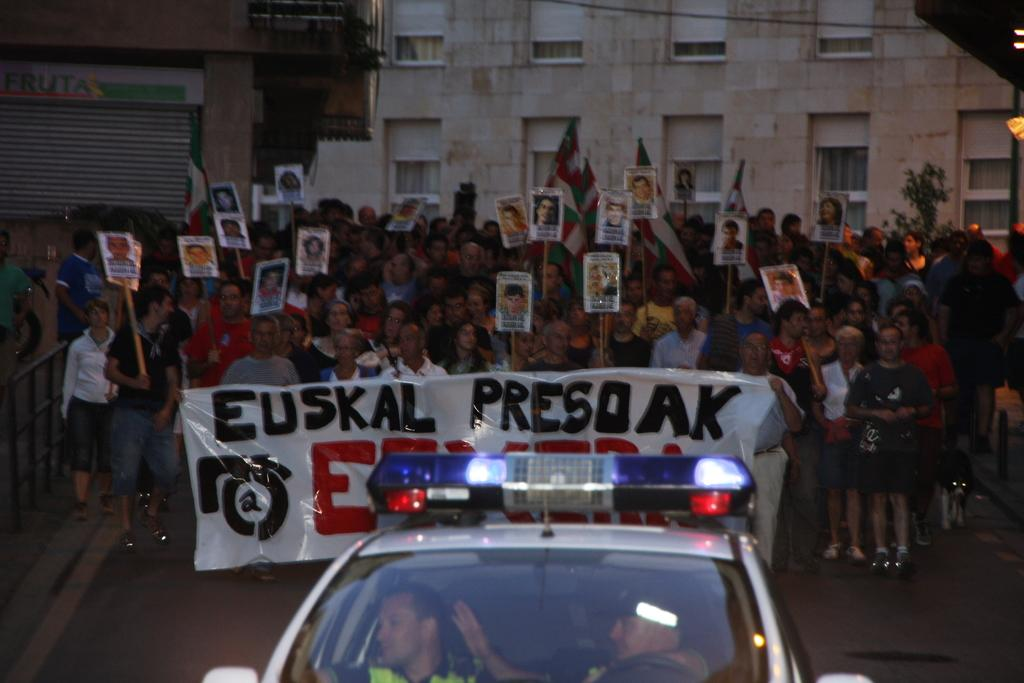What is the main subject of the image? There is a car in the image. Who is inside the car? There are two men in the car. What can be seen in the background of the image? There are people with posters and a banner in the background of the image. What type of structure is visible in the background? There is a building in the background of the image. What type of underwear is the tree wearing in the image? There is no tree or underwear present in the image. What time of day is it in the image, given the presence of morning light? The time of day is not mentioned or indicated in the image. 